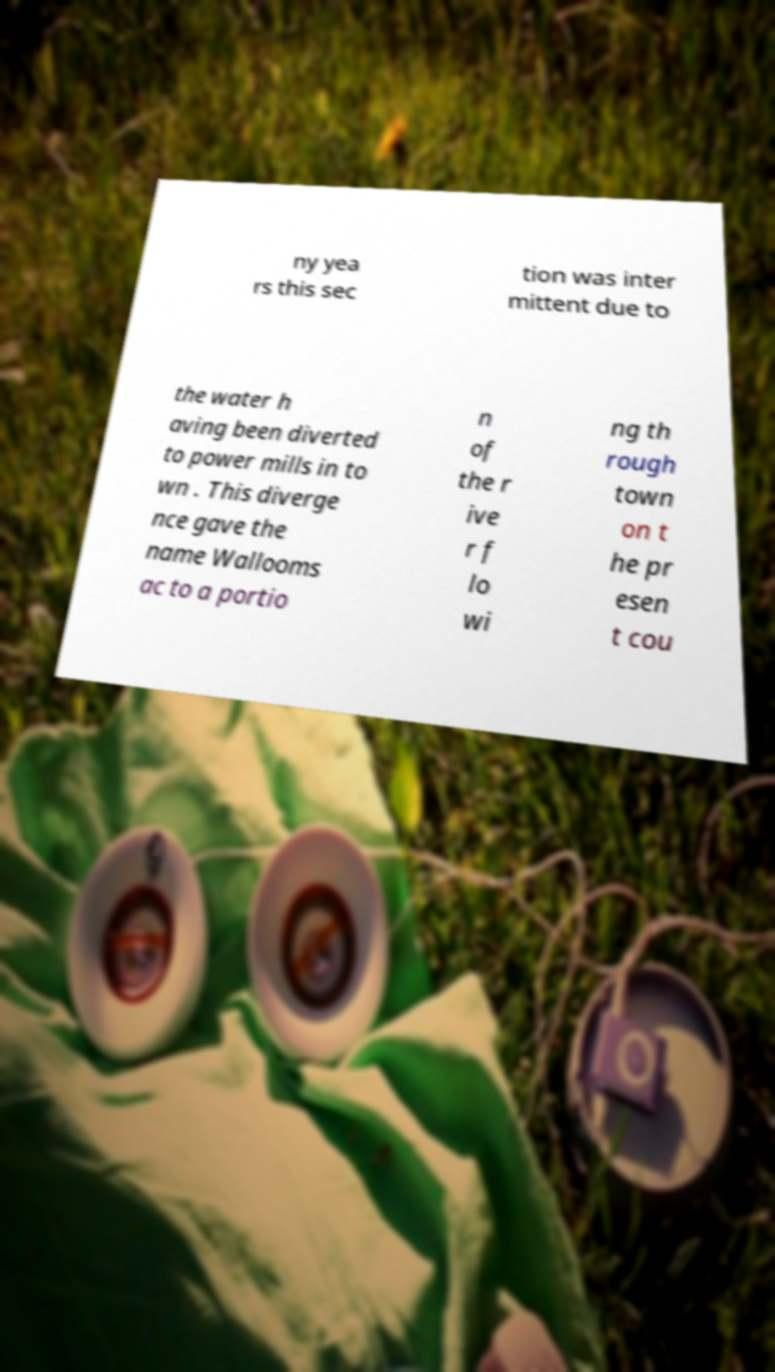Could you assist in decoding the text presented in this image and type it out clearly? ny yea rs this sec tion was inter mittent due to the water h aving been diverted to power mills in to wn . This diverge nce gave the name Wallooms ac to a portio n of the r ive r f lo wi ng th rough town on t he pr esen t cou 